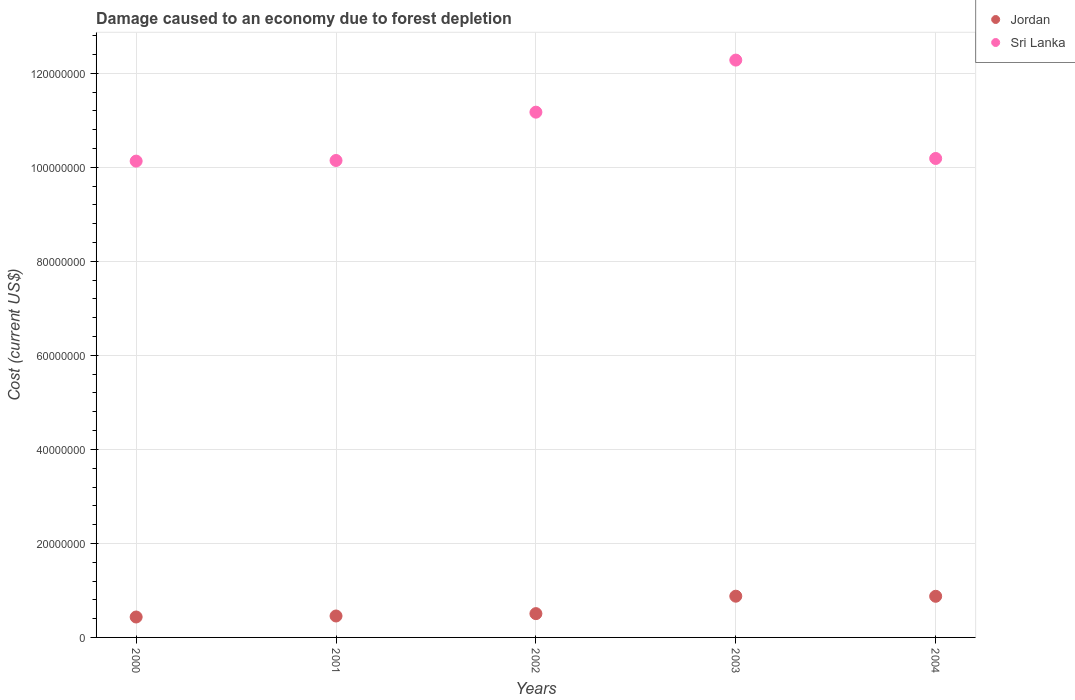How many different coloured dotlines are there?
Offer a very short reply. 2. Is the number of dotlines equal to the number of legend labels?
Your response must be concise. Yes. What is the cost of damage caused due to forest depletion in Sri Lanka in 2002?
Give a very brief answer. 1.12e+08. Across all years, what is the maximum cost of damage caused due to forest depletion in Sri Lanka?
Offer a very short reply. 1.23e+08. Across all years, what is the minimum cost of damage caused due to forest depletion in Jordan?
Provide a succinct answer. 4.35e+06. In which year was the cost of damage caused due to forest depletion in Jordan minimum?
Offer a terse response. 2000. What is the total cost of damage caused due to forest depletion in Jordan in the graph?
Provide a succinct answer. 3.15e+07. What is the difference between the cost of damage caused due to forest depletion in Jordan in 2000 and that in 2002?
Offer a terse response. -7.16e+05. What is the difference between the cost of damage caused due to forest depletion in Sri Lanka in 2004 and the cost of damage caused due to forest depletion in Jordan in 2003?
Keep it short and to the point. 9.31e+07. What is the average cost of damage caused due to forest depletion in Jordan per year?
Make the answer very short. 6.30e+06. In the year 2004, what is the difference between the cost of damage caused due to forest depletion in Jordan and cost of damage caused due to forest depletion in Sri Lanka?
Make the answer very short. -9.31e+07. In how many years, is the cost of damage caused due to forest depletion in Sri Lanka greater than 92000000 US$?
Provide a succinct answer. 5. What is the ratio of the cost of damage caused due to forest depletion in Sri Lanka in 2001 to that in 2002?
Provide a succinct answer. 0.91. Is the difference between the cost of damage caused due to forest depletion in Jordan in 2000 and 2003 greater than the difference between the cost of damage caused due to forest depletion in Sri Lanka in 2000 and 2003?
Your answer should be very brief. Yes. What is the difference between the highest and the second highest cost of damage caused due to forest depletion in Sri Lanka?
Give a very brief answer. 1.11e+07. What is the difference between the highest and the lowest cost of damage caused due to forest depletion in Sri Lanka?
Keep it short and to the point. 2.15e+07. Does the cost of damage caused due to forest depletion in Jordan monotonically increase over the years?
Your response must be concise. No. Does the graph contain grids?
Provide a short and direct response. Yes. What is the title of the graph?
Provide a succinct answer. Damage caused to an economy due to forest depletion. Does "Northern Mariana Islands" appear as one of the legend labels in the graph?
Provide a succinct answer. No. What is the label or title of the X-axis?
Keep it short and to the point. Years. What is the label or title of the Y-axis?
Give a very brief answer. Cost (current US$). What is the Cost (current US$) of Jordan in 2000?
Offer a terse response. 4.35e+06. What is the Cost (current US$) of Sri Lanka in 2000?
Offer a very short reply. 1.01e+08. What is the Cost (current US$) in Jordan in 2001?
Your answer should be compact. 4.56e+06. What is the Cost (current US$) in Sri Lanka in 2001?
Offer a terse response. 1.01e+08. What is the Cost (current US$) of Jordan in 2002?
Your answer should be compact. 5.06e+06. What is the Cost (current US$) in Sri Lanka in 2002?
Offer a very short reply. 1.12e+08. What is the Cost (current US$) in Jordan in 2003?
Make the answer very short. 8.77e+06. What is the Cost (current US$) in Sri Lanka in 2003?
Make the answer very short. 1.23e+08. What is the Cost (current US$) of Jordan in 2004?
Offer a very short reply. 8.75e+06. What is the Cost (current US$) of Sri Lanka in 2004?
Ensure brevity in your answer.  1.02e+08. Across all years, what is the maximum Cost (current US$) in Jordan?
Keep it short and to the point. 8.77e+06. Across all years, what is the maximum Cost (current US$) in Sri Lanka?
Offer a terse response. 1.23e+08. Across all years, what is the minimum Cost (current US$) of Jordan?
Give a very brief answer. 4.35e+06. Across all years, what is the minimum Cost (current US$) of Sri Lanka?
Keep it short and to the point. 1.01e+08. What is the total Cost (current US$) of Jordan in the graph?
Your response must be concise. 3.15e+07. What is the total Cost (current US$) in Sri Lanka in the graph?
Ensure brevity in your answer.  5.39e+08. What is the difference between the Cost (current US$) in Jordan in 2000 and that in 2001?
Offer a very short reply. -2.15e+05. What is the difference between the Cost (current US$) of Sri Lanka in 2000 and that in 2001?
Give a very brief answer. -1.34e+05. What is the difference between the Cost (current US$) in Jordan in 2000 and that in 2002?
Your answer should be very brief. -7.16e+05. What is the difference between the Cost (current US$) of Sri Lanka in 2000 and that in 2002?
Offer a very short reply. -1.04e+07. What is the difference between the Cost (current US$) in Jordan in 2000 and that in 2003?
Keep it short and to the point. -4.43e+06. What is the difference between the Cost (current US$) in Sri Lanka in 2000 and that in 2003?
Ensure brevity in your answer.  -2.15e+07. What is the difference between the Cost (current US$) of Jordan in 2000 and that in 2004?
Your response must be concise. -4.41e+06. What is the difference between the Cost (current US$) of Sri Lanka in 2000 and that in 2004?
Make the answer very short. -5.61e+05. What is the difference between the Cost (current US$) in Jordan in 2001 and that in 2002?
Make the answer very short. -5.01e+05. What is the difference between the Cost (current US$) in Sri Lanka in 2001 and that in 2002?
Offer a very short reply. -1.03e+07. What is the difference between the Cost (current US$) of Jordan in 2001 and that in 2003?
Keep it short and to the point. -4.21e+06. What is the difference between the Cost (current US$) in Sri Lanka in 2001 and that in 2003?
Your response must be concise. -2.14e+07. What is the difference between the Cost (current US$) of Jordan in 2001 and that in 2004?
Keep it short and to the point. -4.19e+06. What is the difference between the Cost (current US$) of Sri Lanka in 2001 and that in 2004?
Your response must be concise. -4.27e+05. What is the difference between the Cost (current US$) in Jordan in 2002 and that in 2003?
Offer a terse response. -3.71e+06. What is the difference between the Cost (current US$) in Sri Lanka in 2002 and that in 2003?
Offer a terse response. -1.11e+07. What is the difference between the Cost (current US$) of Jordan in 2002 and that in 2004?
Offer a terse response. -3.69e+06. What is the difference between the Cost (current US$) in Sri Lanka in 2002 and that in 2004?
Provide a short and direct response. 9.85e+06. What is the difference between the Cost (current US$) of Jordan in 2003 and that in 2004?
Your response must be concise. 1.99e+04. What is the difference between the Cost (current US$) in Sri Lanka in 2003 and that in 2004?
Give a very brief answer. 2.09e+07. What is the difference between the Cost (current US$) of Jordan in 2000 and the Cost (current US$) of Sri Lanka in 2001?
Give a very brief answer. -9.71e+07. What is the difference between the Cost (current US$) in Jordan in 2000 and the Cost (current US$) in Sri Lanka in 2002?
Make the answer very short. -1.07e+08. What is the difference between the Cost (current US$) in Jordan in 2000 and the Cost (current US$) in Sri Lanka in 2003?
Your answer should be very brief. -1.18e+08. What is the difference between the Cost (current US$) in Jordan in 2000 and the Cost (current US$) in Sri Lanka in 2004?
Ensure brevity in your answer.  -9.75e+07. What is the difference between the Cost (current US$) in Jordan in 2001 and the Cost (current US$) in Sri Lanka in 2002?
Offer a terse response. -1.07e+08. What is the difference between the Cost (current US$) in Jordan in 2001 and the Cost (current US$) in Sri Lanka in 2003?
Ensure brevity in your answer.  -1.18e+08. What is the difference between the Cost (current US$) in Jordan in 2001 and the Cost (current US$) in Sri Lanka in 2004?
Provide a succinct answer. -9.73e+07. What is the difference between the Cost (current US$) in Jordan in 2002 and the Cost (current US$) in Sri Lanka in 2003?
Ensure brevity in your answer.  -1.18e+08. What is the difference between the Cost (current US$) in Jordan in 2002 and the Cost (current US$) in Sri Lanka in 2004?
Ensure brevity in your answer.  -9.68e+07. What is the difference between the Cost (current US$) of Jordan in 2003 and the Cost (current US$) of Sri Lanka in 2004?
Keep it short and to the point. -9.31e+07. What is the average Cost (current US$) of Jordan per year?
Your answer should be very brief. 6.30e+06. What is the average Cost (current US$) in Sri Lanka per year?
Your answer should be compact. 1.08e+08. In the year 2000, what is the difference between the Cost (current US$) of Jordan and Cost (current US$) of Sri Lanka?
Your answer should be compact. -9.70e+07. In the year 2001, what is the difference between the Cost (current US$) of Jordan and Cost (current US$) of Sri Lanka?
Provide a short and direct response. -9.69e+07. In the year 2002, what is the difference between the Cost (current US$) of Jordan and Cost (current US$) of Sri Lanka?
Offer a terse response. -1.07e+08. In the year 2003, what is the difference between the Cost (current US$) of Jordan and Cost (current US$) of Sri Lanka?
Give a very brief answer. -1.14e+08. In the year 2004, what is the difference between the Cost (current US$) of Jordan and Cost (current US$) of Sri Lanka?
Provide a succinct answer. -9.31e+07. What is the ratio of the Cost (current US$) in Jordan in 2000 to that in 2001?
Provide a succinct answer. 0.95. What is the ratio of the Cost (current US$) in Jordan in 2000 to that in 2002?
Keep it short and to the point. 0.86. What is the ratio of the Cost (current US$) of Sri Lanka in 2000 to that in 2002?
Keep it short and to the point. 0.91. What is the ratio of the Cost (current US$) of Jordan in 2000 to that in 2003?
Offer a very short reply. 0.5. What is the ratio of the Cost (current US$) of Sri Lanka in 2000 to that in 2003?
Provide a succinct answer. 0.82. What is the ratio of the Cost (current US$) of Jordan in 2000 to that in 2004?
Your answer should be very brief. 0.5. What is the ratio of the Cost (current US$) in Jordan in 2001 to that in 2002?
Offer a very short reply. 0.9. What is the ratio of the Cost (current US$) in Sri Lanka in 2001 to that in 2002?
Ensure brevity in your answer.  0.91. What is the ratio of the Cost (current US$) in Jordan in 2001 to that in 2003?
Your response must be concise. 0.52. What is the ratio of the Cost (current US$) in Sri Lanka in 2001 to that in 2003?
Ensure brevity in your answer.  0.83. What is the ratio of the Cost (current US$) in Jordan in 2001 to that in 2004?
Ensure brevity in your answer.  0.52. What is the ratio of the Cost (current US$) of Sri Lanka in 2001 to that in 2004?
Your answer should be compact. 1. What is the ratio of the Cost (current US$) of Jordan in 2002 to that in 2003?
Offer a terse response. 0.58. What is the ratio of the Cost (current US$) of Sri Lanka in 2002 to that in 2003?
Ensure brevity in your answer.  0.91. What is the ratio of the Cost (current US$) in Jordan in 2002 to that in 2004?
Offer a terse response. 0.58. What is the ratio of the Cost (current US$) in Sri Lanka in 2002 to that in 2004?
Your answer should be very brief. 1.1. What is the ratio of the Cost (current US$) in Jordan in 2003 to that in 2004?
Offer a very short reply. 1. What is the ratio of the Cost (current US$) in Sri Lanka in 2003 to that in 2004?
Your response must be concise. 1.21. What is the difference between the highest and the second highest Cost (current US$) in Jordan?
Provide a succinct answer. 1.99e+04. What is the difference between the highest and the second highest Cost (current US$) in Sri Lanka?
Ensure brevity in your answer.  1.11e+07. What is the difference between the highest and the lowest Cost (current US$) of Jordan?
Make the answer very short. 4.43e+06. What is the difference between the highest and the lowest Cost (current US$) of Sri Lanka?
Ensure brevity in your answer.  2.15e+07. 